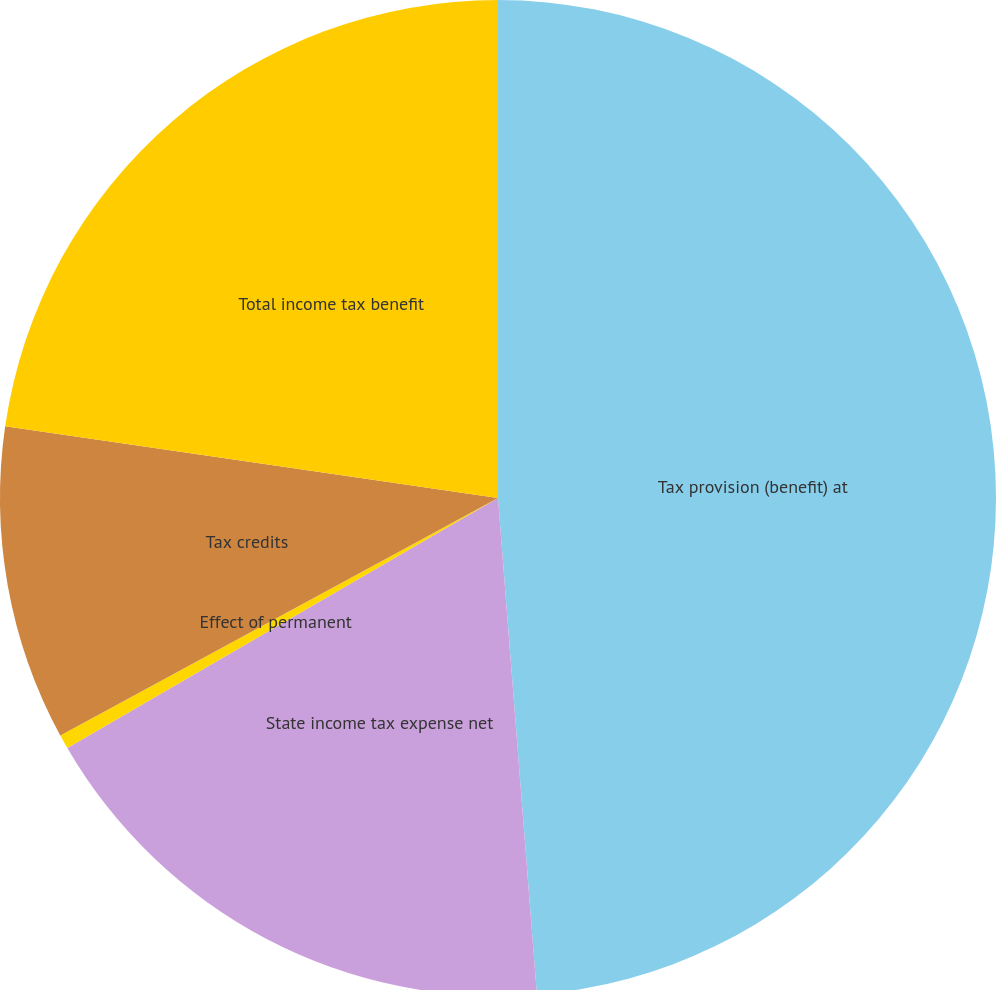Convert chart. <chart><loc_0><loc_0><loc_500><loc_500><pie_chart><fcel>Tax provision (benefit) at<fcel>State income tax expense net<fcel>Effect of permanent<fcel>Tax credits<fcel>Total income tax benefit<nl><fcel>48.75%<fcel>17.87%<fcel>0.46%<fcel>10.21%<fcel>22.7%<nl></chart> 